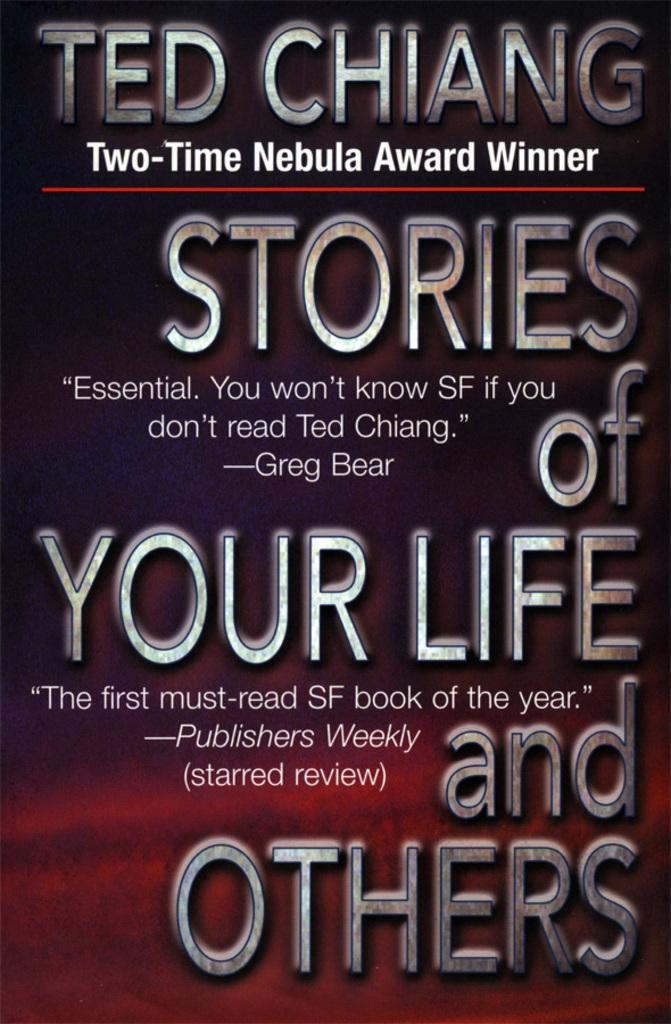<image>
Describe the image concisely. A print edition of Ted Chiang's book Stories of Your Life and Others. 